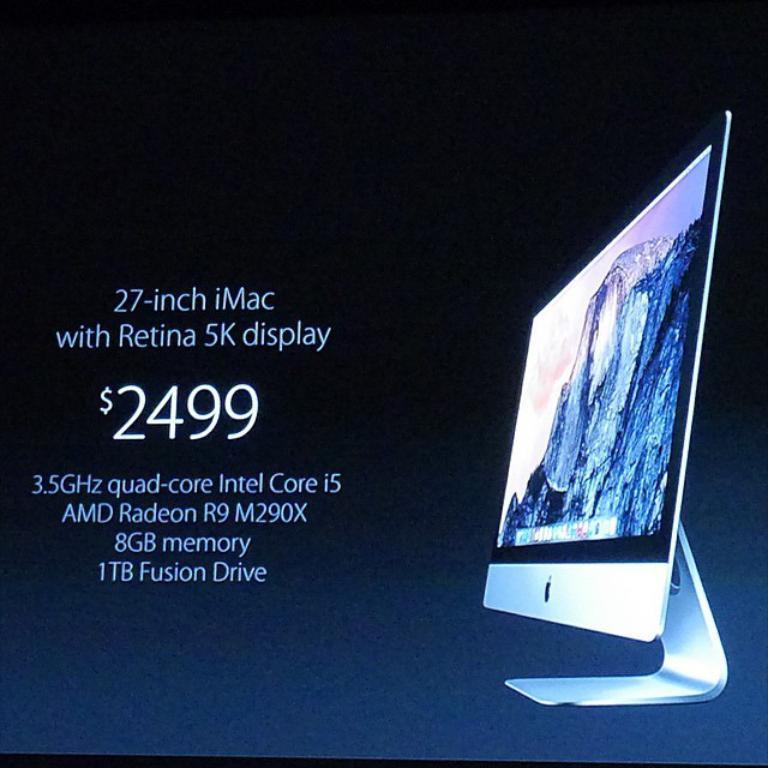<image>
Present a compact description of the photo's key features. An ad about a 27 inch i mac comptuer for 2499 with a 5k display. 